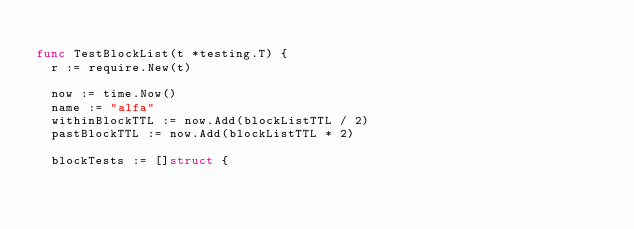<code> <loc_0><loc_0><loc_500><loc_500><_Go_>
func TestBlockList(t *testing.T) {
	r := require.New(t)

	now := time.Now()
	name := "alfa"
	withinBlockTTL := now.Add(blockListTTL / 2)
	pastBlockTTL := now.Add(blockListTTL * 2)

	blockTests := []struct {</code> 